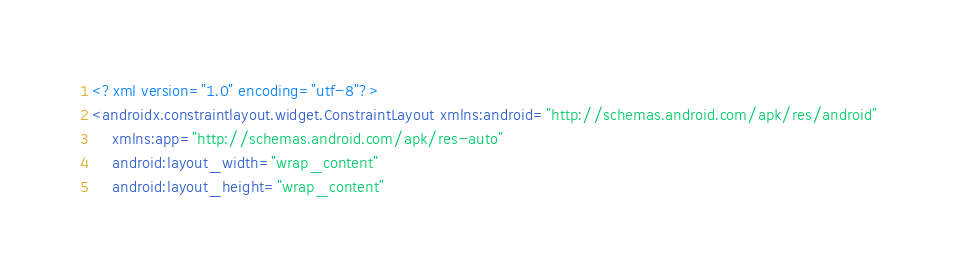Convert code to text. <code><loc_0><loc_0><loc_500><loc_500><_XML_><?xml version="1.0" encoding="utf-8"?>
<androidx.constraintlayout.widget.ConstraintLayout xmlns:android="http://schemas.android.com/apk/res/android"
    xmlns:app="http://schemas.android.com/apk/res-auto"
    android:layout_width="wrap_content"
    android:layout_height="wrap_content"</code> 